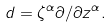<formula> <loc_0><loc_0><loc_500><loc_500>d = \zeta ^ { \alpha } \partial / \partial z ^ { \alpha } .</formula> 